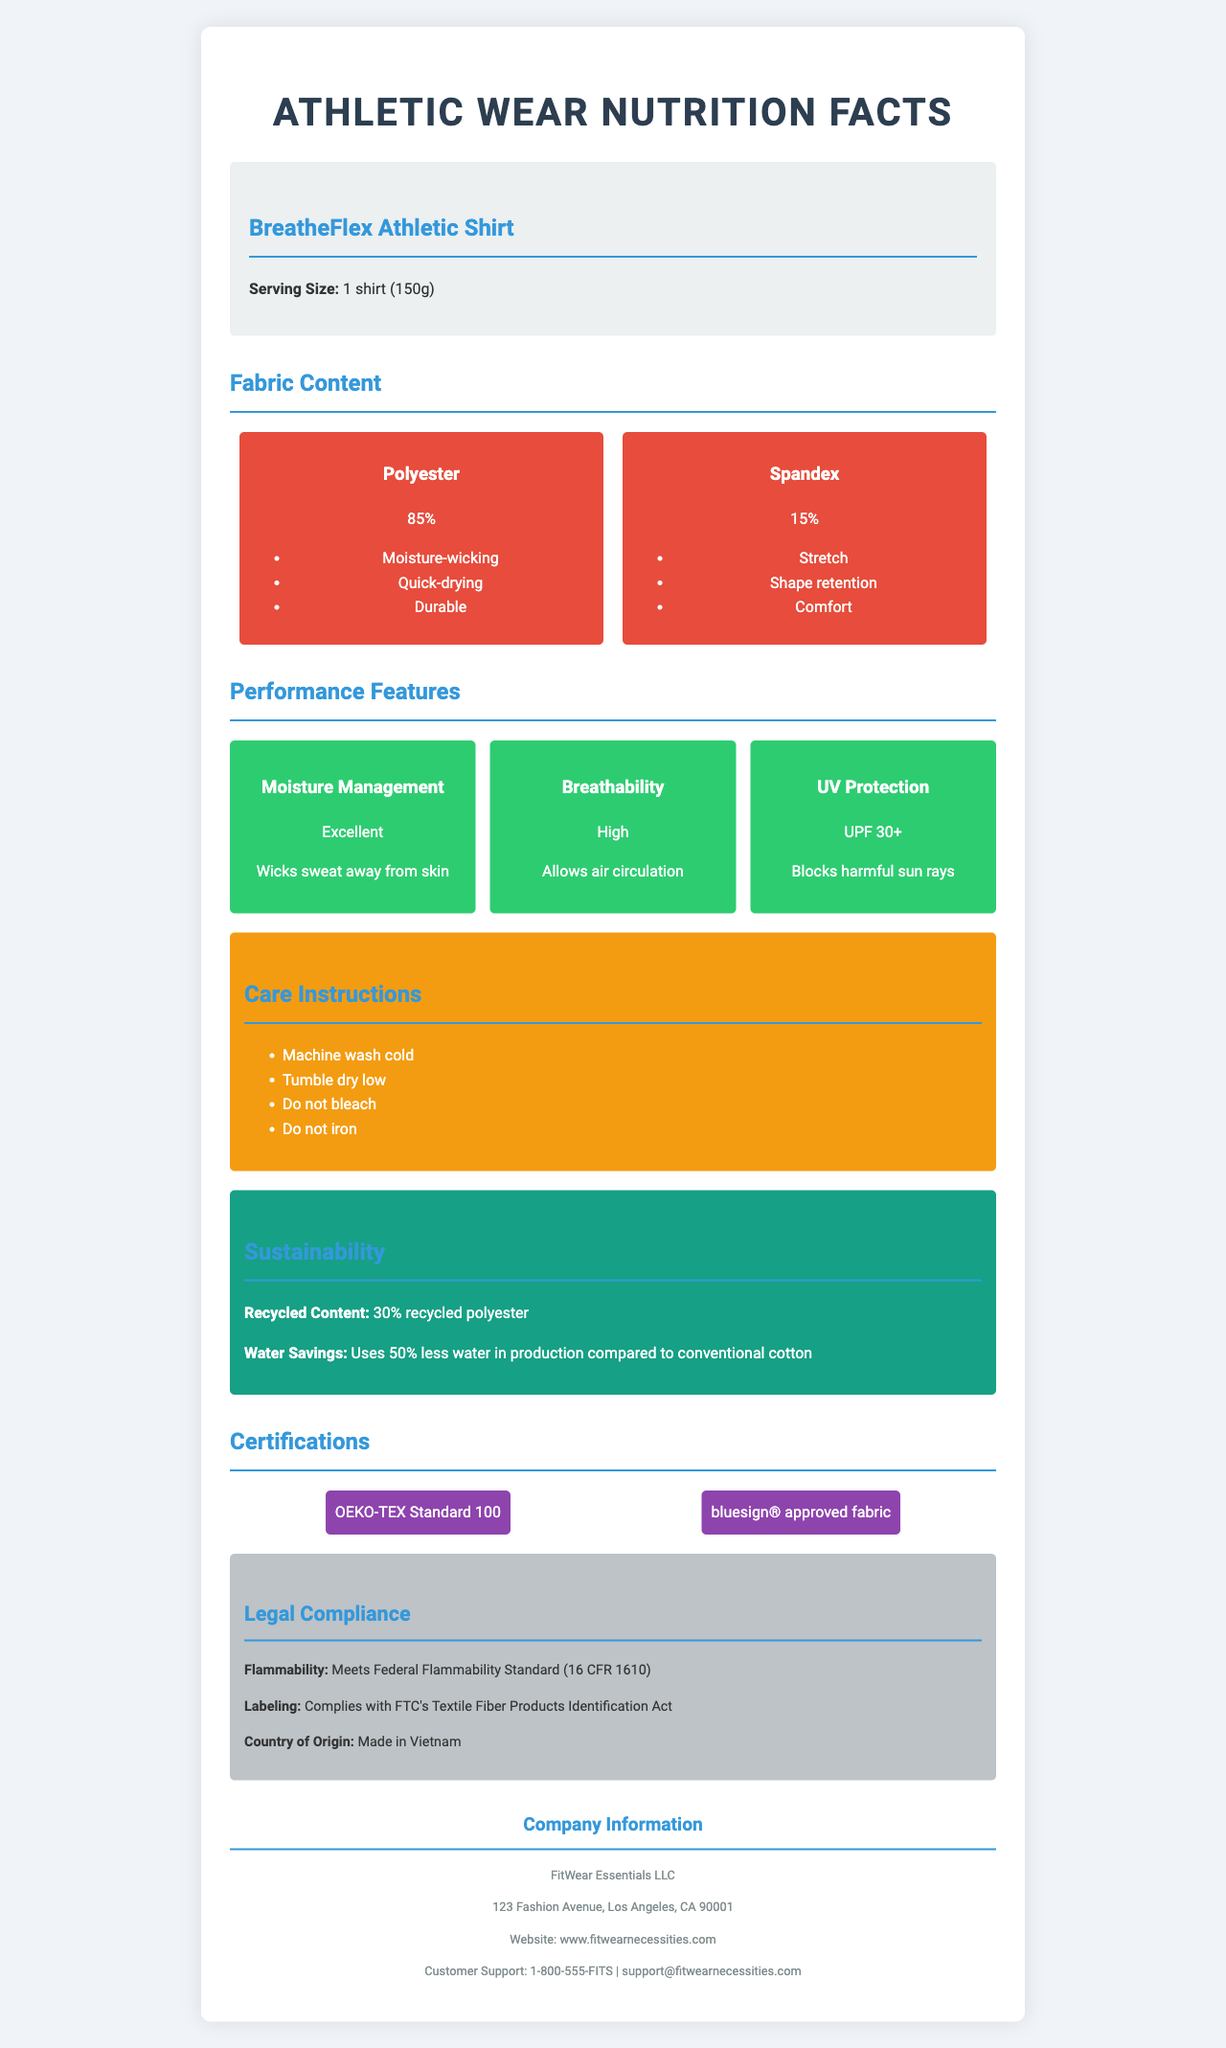what is the serving size of the BreatheFlex Athletic Shirt? The document specifies the serving size as 1 shirt (150g) in the product info section.
Answer: 1 shirt (150g) what are the main fabrics used in the BreatheFlex Athletic Shirt? The fabric content section lists Polyester and Spandex as the main fabrics, with percentages of 85% and 15%, respectively.
Answer: Polyester and Spandex what are the benefits of Polyester mentioned in the document? Under the fabric content section, Polyester is listed with benefits such as Moisture-wicking, Quick-drying, and Durable.
Answer: Moisture-wicking, Quick-drying, Durable how can the BreatheFlex Athletic Shirt be washed? The care instructions section outlines that the shirt should be machine washed cold, tumbled dry low, not bleached, and not ironed.
Answer: Machine wash cold, Tumble dry low, Do not bleach, Do not iron where is the BreatheFlex Athletic Shirt made? The country of origin is specified as Made in Vietnam in the legal compliance section.
Answer: Made in Vietnam which performance feature has a UV Protection value, and what is the value? The performance features section lists UV Protection with a value of UPF 30+.
Answer: UV Protection, UPF 30+ what certifications does the BreatheFlex Athletic Shirt have? The certifications section mentions OEKO-TEX Standard 100 and bluesign® approved fabric.
Answer: OEKO-TEX Standard 100, bluesign® approved fabric how much recycled polyester content is in the BreatheFlex Athletic Shirt? The sustainability section states that the shirt is made with 30% recycled polyester.
Answer: 30% recycled polyester which category does the benefit "Wicks sweat away from skin" fall under? A. Fabric Content B. Performance Features C. Care Instructions "Wicks sweat away from skin" is described under the "Moisture Management" feature in the Performance Features section.
Answer: B what is the description for the breathability feature in the performance features section? A. Excellent B. UPF 30+ C. Allows air circulation D. Moisture-wicking The breathability feature is described as "Allows air circulation" in the performance features section.
Answer: C does the BreatheFlex Athletic Shirt comply with the Federal Flammability Standard? The legal compliance section states that the shirt meets the Federal Flammability Standard (16 CFR 1610).
Answer: Yes is the BreatheFlex Athletic Shirt ironable? The care instructions explicitly mention "Do not iron."
Answer: No summarize the main features and compliance of the BreatheFlex Athletic Shirt. The document details the fabric content, performance features, care instructions, sustainability, certifications, and legal compliance of the BreatheFlex Athletic Shirt, emphasizing its functionality and eco-friendliness.
Answer: The BreatheFlex Athletic Shirt is made primarily from Polyester (85%) and Spandex (15%), providing moisture-wicking, quick-drying, stretch, and comfort features. It has excellent moisture management, high breathability, and UV protection (UPF 30+). Care instructions include machine wash cold and tumble dry low. It contains 30% recycled polyester and meets sustainability and legal compliance standards including the Federal Flammability Standard and FTC's Textile Fiber Products Identification Act. The shirt is made in Vietnam and certified by OEKO-TEX and bluesign®. who is the CEO of FitWear Essentials LLC? The document provides the company's name, address, website, and customer support details, but does not list the CEO.
Answer: Not enough information 